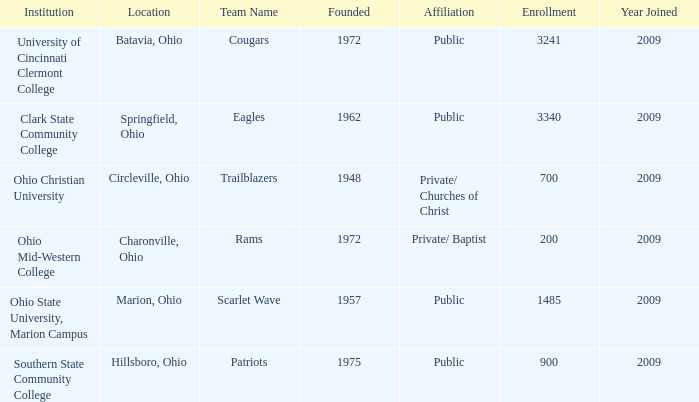What is the institution that was located is circleville, ohio? Ohio Christian University. 